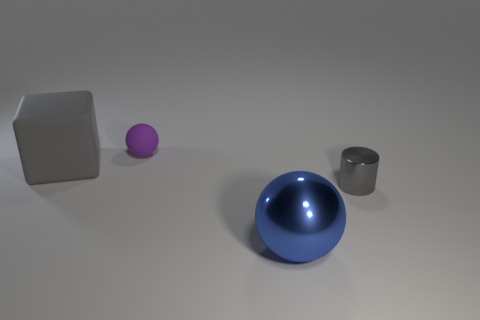Do the large object that is to the right of the purple matte ball and the small purple rubber object have the same shape?
Offer a very short reply. Yes. The small ball has what color?
Give a very brief answer. Purple. There is a tiny thing that is the same color as the rubber cube; what is its shape?
Provide a short and direct response. Cylinder. Is there a ball?
Your response must be concise. Yes. The purple object that is the same material as the block is what size?
Keep it short and to the point. Small. What shape is the tiny thing that is in front of the gray thing that is to the left of the large object in front of the small gray metallic cylinder?
Offer a very short reply. Cylinder. Are there an equal number of purple rubber balls that are to the left of the blue metal thing and brown metal blocks?
Provide a succinct answer. No. The metallic thing that is the same color as the block is what size?
Give a very brief answer. Small. Is the shape of the large blue object the same as the tiny purple rubber thing?
Offer a terse response. Yes. How many objects are metal things that are on the left side of the gray shiny thing or things?
Offer a very short reply. 4. 